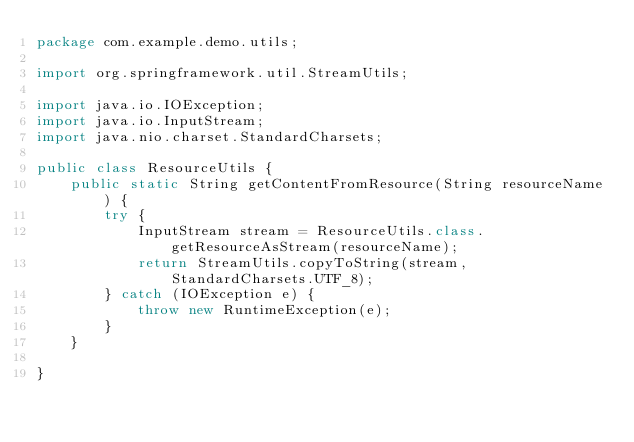Convert code to text. <code><loc_0><loc_0><loc_500><loc_500><_Java_>package com.example.demo.utils;

import org.springframework.util.StreamUtils;

import java.io.IOException;
import java.io.InputStream;
import java.nio.charset.StandardCharsets;

public class ResourceUtils {
    public static String getContentFromResource(String resourceName) {
        try {
            InputStream stream = ResourceUtils.class.getResourceAsStream(resourceName);
            return StreamUtils.copyToString(stream, StandardCharsets.UTF_8);
        } catch (IOException e) {
            throw new RuntimeException(e);
        }
    }

}
</code> 